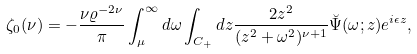<formula> <loc_0><loc_0><loc_500><loc_500>\zeta _ { 0 } ( \nu ) = - { \frac { \nu \varrho ^ { - 2 \nu } } { \pi } } \int _ { \mu } ^ { \infty } d \omega \int _ { C _ { + } } d z { \frac { 2 z ^ { 2 } } { ( z ^ { 2 } + \omega ^ { 2 } ) ^ { \nu + 1 } } } \breve { \Psi } ( \omega ; z ) e ^ { i \epsilon z } ,</formula> 